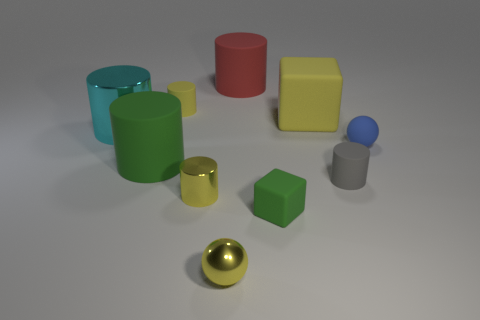Is the color of the tiny shiny sphere the same as the large matte object to the right of the big red rubber thing?
Offer a very short reply. Yes. The object that is the same color as the tiny block is what shape?
Ensure brevity in your answer.  Cylinder. There is a red thing that is the same shape as the big cyan thing; what is its size?
Provide a succinct answer. Large. Is the shape of the yellow rubber object on the right side of the red matte cylinder the same as  the tiny green thing?
Your response must be concise. Yes. There is a big object on the right side of the green thing that is on the right side of the green rubber cylinder; is there a yellow shiny cylinder that is in front of it?
Offer a very short reply. Yes. What number of shiny spheres have the same color as the small matte block?
Your answer should be compact. 0. There is a yellow matte thing that is the same size as the blue thing; what is its shape?
Keep it short and to the point. Cylinder. Are there any metallic cylinders to the right of the green cylinder?
Keep it short and to the point. Yes. Is the size of the red cylinder the same as the green matte cube?
Make the answer very short. No. The big matte object in front of the blue thing has what shape?
Your answer should be compact. Cylinder. 